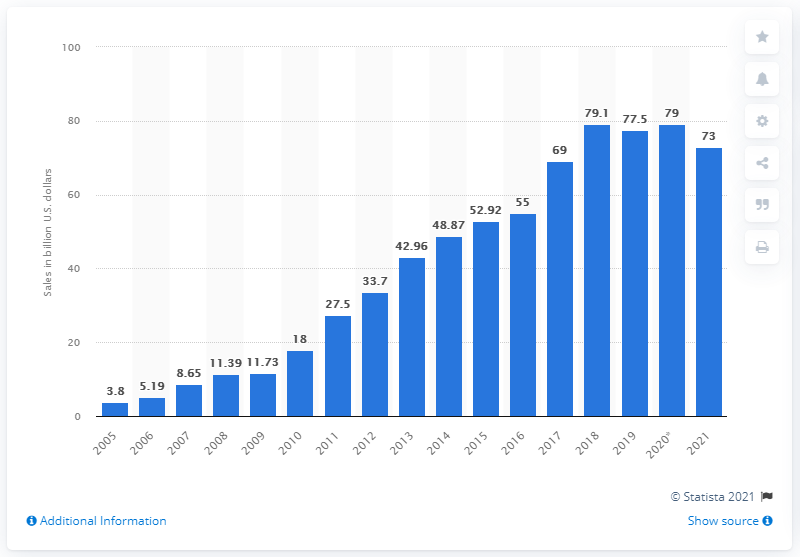Specify some key components in this picture. According to the forecast for 2021, revenue in the United States is predicted to be 73. In January 2020, the estimated sales value of smartphones in the U.S. was approximately $79 billion. 